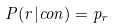<formula> <loc_0><loc_0><loc_500><loc_500>P ( r | c o n ) = p _ { r }</formula> 